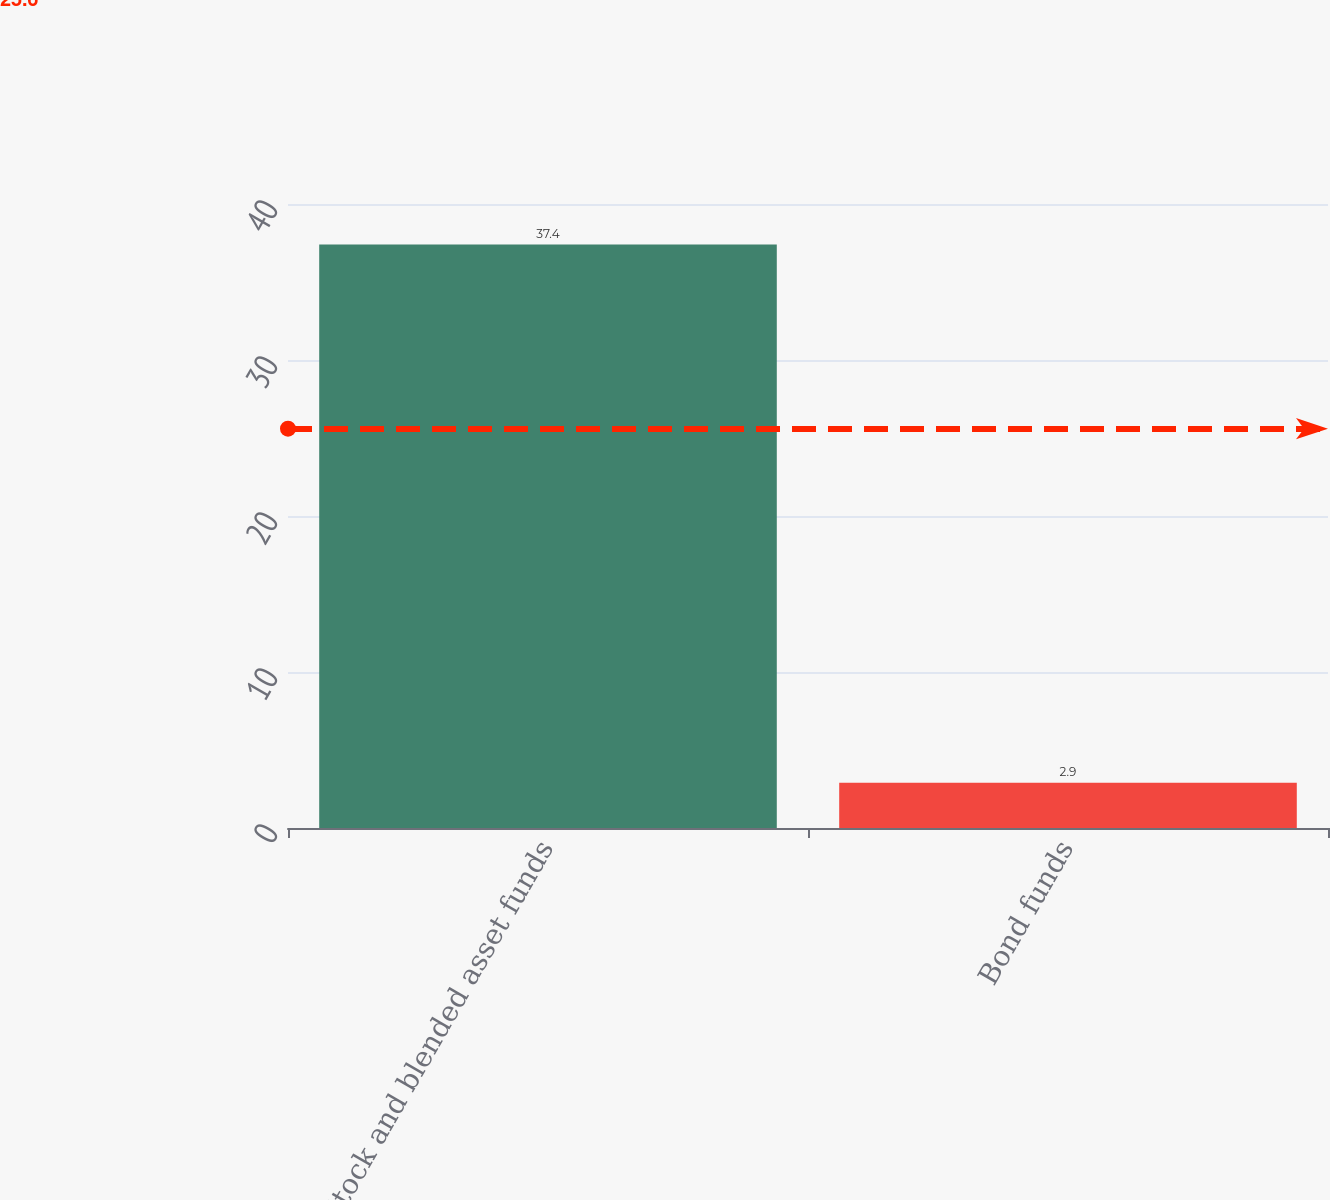<chart> <loc_0><loc_0><loc_500><loc_500><bar_chart><fcel>Stock and blended asset funds<fcel>Bond funds<nl><fcel>37.4<fcel>2.9<nl></chart> 